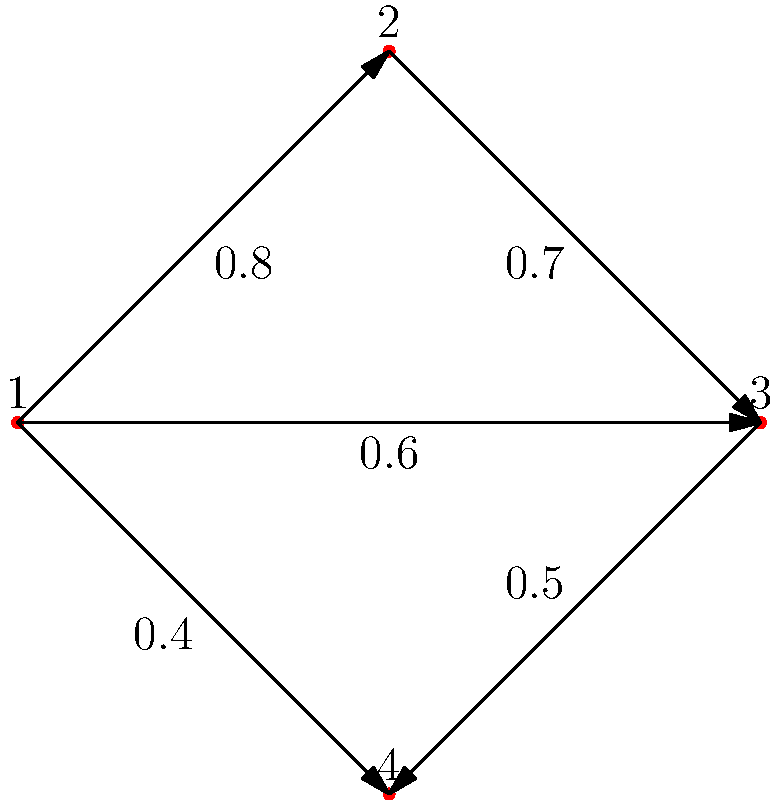In this weighted graph representing coffee flavor profiles, vertices represent different coffee types, and edge weights represent flavor similarity (higher weight means more similar). If we define a similarity threshold of 0.6, what is the size of the largest connected component in the graph? To solve this problem, we need to follow these steps:

1. Understand the graph representation:
   - Vertices (1, 2, 3, 4) represent different coffee types.
   - Edge weights represent flavor similarity (higher weight = more similar).
   - Similarity threshold is 0.6.

2. Identify edges meeting the threshold:
   - Edge 1-2: weight 0.8 > 0.6
   - Edge 1-3: weight 0.6 = 0.6
   - Edge 1-4: weight 0.4 < 0.6 (ignored)
   - Edge 2-3: weight 0.7 > 0.6
   - Edge 3-4: weight 0.5 < 0.6 (ignored)

3. Construct the subgraph with edges meeting the threshold:
   - Vertices: 1, 2, 3
   - Edges: 1-2, 1-3, 2-3

4. Identify connected components:
   - There is only one connected component: {1, 2, 3}

5. Determine the size of the largest connected component:
   - The size is 3 (vertices 1, 2, and 3 are connected)

Therefore, the size of the largest connected component in the graph, considering the similarity threshold of 0.6, is 3.
Answer: 3 